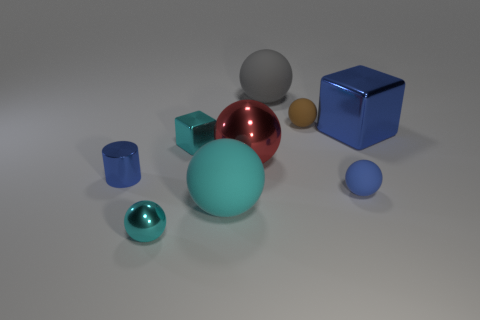Subtract all metallic spheres. How many spheres are left? 4 Subtract all gray cylinders. How many cyan balls are left? 2 Add 1 tiny rubber balls. How many objects exist? 10 Subtract all blue blocks. How many blocks are left? 1 Subtract all cubes. How many objects are left? 7 Add 5 big gray rubber things. How many big gray rubber things are left? 6 Add 7 tiny shiny objects. How many tiny shiny objects exist? 10 Subtract 1 blue cubes. How many objects are left? 8 Subtract 1 blocks. How many blocks are left? 1 Subtract all green cubes. Subtract all brown cylinders. How many cubes are left? 2 